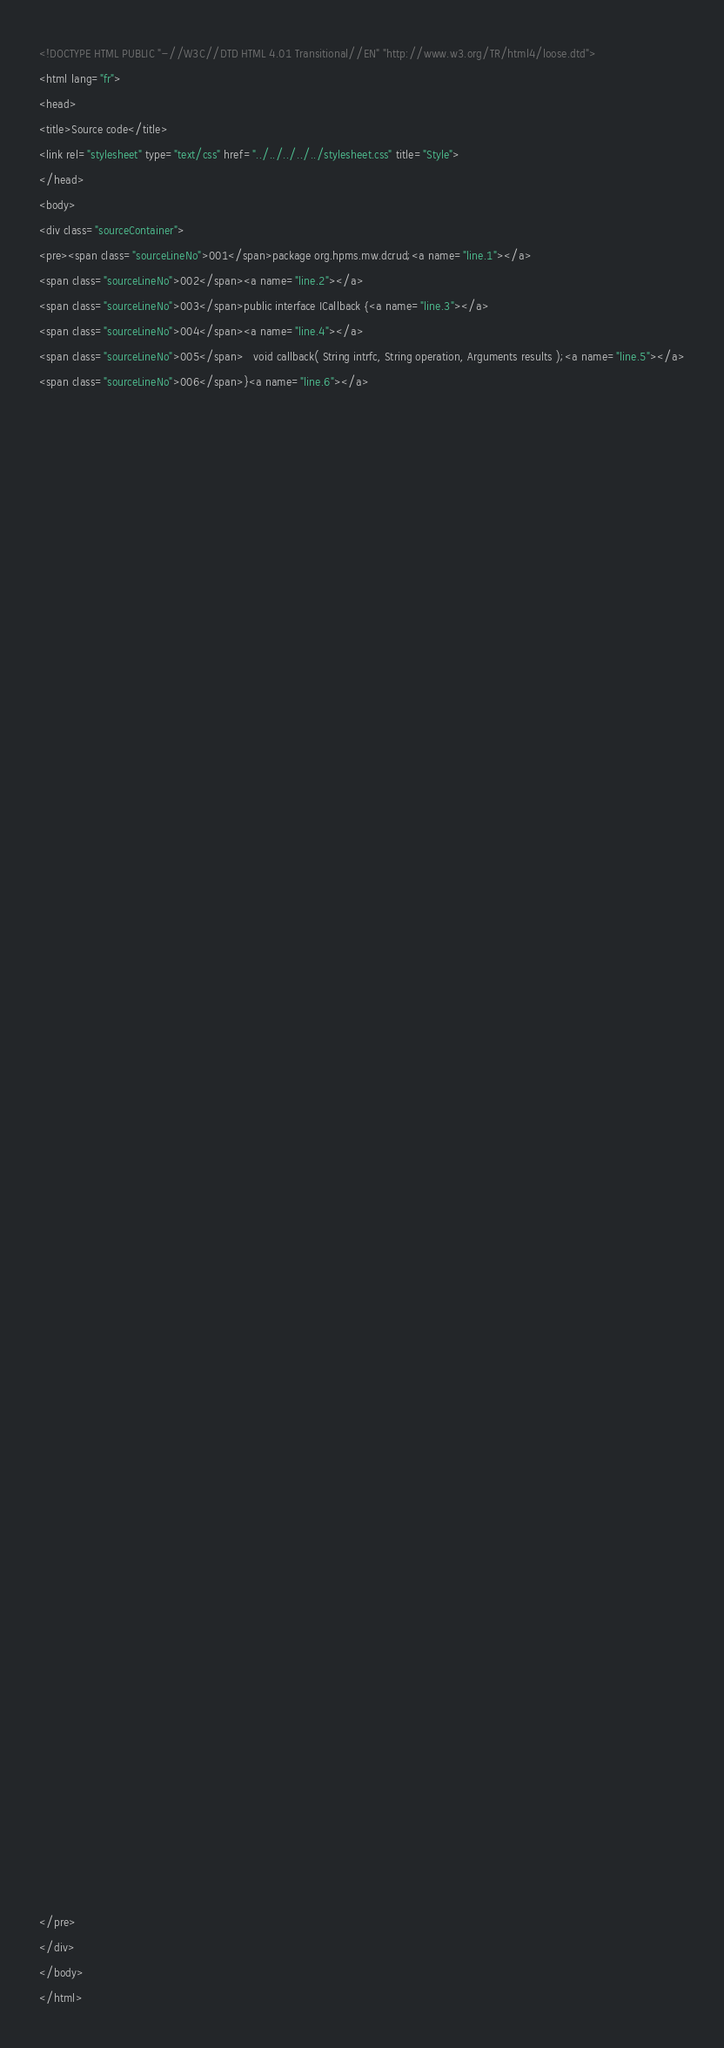Convert code to text. <code><loc_0><loc_0><loc_500><loc_500><_HTML_><!DOCTYPE HTML PUBLIC "-//W3C//DTD HTML 4.01 Transitional//EN" "http://www.w3.org/TR/html4/loose.dtd">
<html lang="fr">
<head>
<title>Source code</title>
<link rel="stylesheet" type="text/css" href="../../../../../stylesheet.css" title="Style">
</head>
<body>
<div class="sourceContainer">
<pre><span class="sourceLineNo">001</span>package org.hpms.mw.dcrud;<a name="line.1"></a>
<span class="sourceLineNo">002</span><a name="line.2"></a>
<span class="sourceLineNo">003</span>public interface ICallback {<a name="line.3"></a>
<span class="sourceLineNo">004</span><a name="line.4"></a>
<span class="sourceLineNo">005</span>   void callback( String intrfc, String operation, Arguments results );<a name="line.5"></a>
<span class="sourceLineNo">006</span>}<a name="line.6"></a>




























































</pre>
</div>
</body>
</html>
</code> 